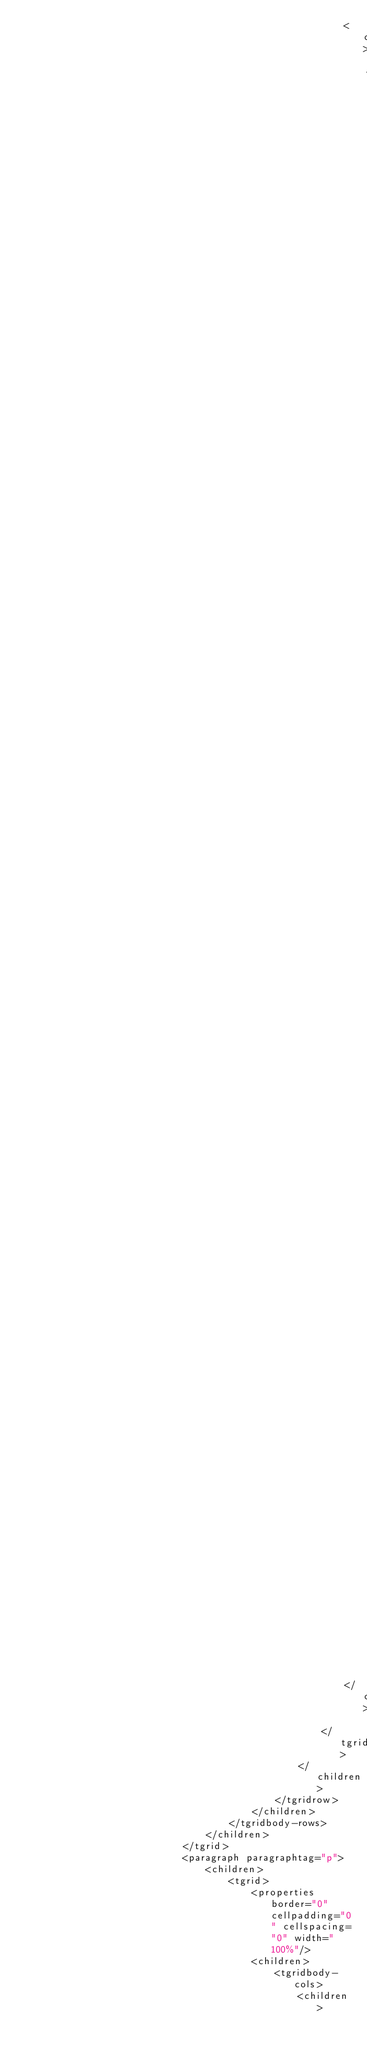<code> <loc_0><loc_0><loc_500><loc_500><_Scheme_>														<children>
															<template subtype="element" match="n1:Committee">
																<children>
																	<template subtype="element" match="n1:CommitteeMasterData">
																		<children>
																			<template subtype="element" match="n1:CommitteeName">
																				<children>
																					<content>
																						<styles font-weight="bold"/>
																						<format basic-type="xsd" datatype="string"/>
																					</content>
																				</children>
																				<variables/>
																			</template>
																		</children>
																		<variables/>
																	</template>
																</children>
																<variables/>
															</template>
														</children>
													</tgridcell>
												</children>
											</tgridrow>
										</children>
									</tgridbody-rows>
								</children>
							</tgrid>
							<paragraph paragraphtag="p">
								<children>
									<tgrid>
										<properties border="0" cellpadding="0" cellspacing="0" width="100%"/>
										<children>
											<tgridbody-cols>
												<children></code> 